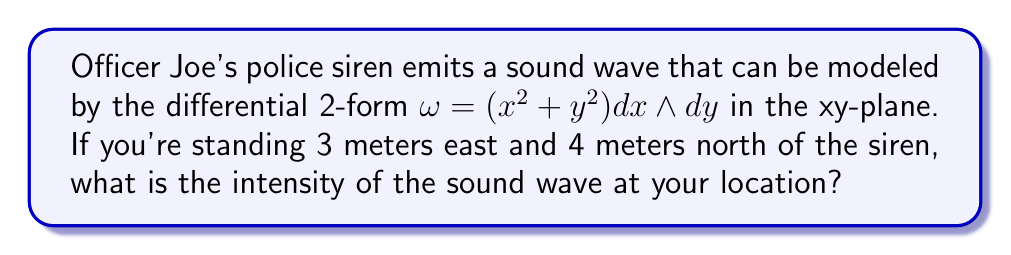Give your solution to this math problem. Let's approach this step-by-step:

1) First, we need to understand what the question is asking. The intensity of the sound wave is represented by the value of the differential 2-form $\omega$ at the given point.

2) We're given that $\omega = (x^2 + y^2) dx \wedge dy$.

3) Our location is 3 meters east and 4 meters north of the siren. In the xy-plane, this corresponds to the point (3, 4).

4) To find the intensity, we need to evaluate $\omega$ at (3, 4). This means we substitute x = 3 and y = 4 into the expression for $\omega$.

5) Let's calculate:
   $\omega_{(3,4)} = (3^2 + 4^2) dx \wedge dy$

6) Simplify:
   $\omega_{(3,4)} = (9 + 16) dx \wedge dy = 25 dx \wedge dy$

7) The value 25 represents the coefficient of the differential form at the point (3, 4), which corresponds to the intensity of the sound wave at that location.
Answer: 25 